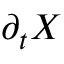<formula> <loc_0><loc_0><loc_500><loc_500>\partial _ { t } { X }</formula> 